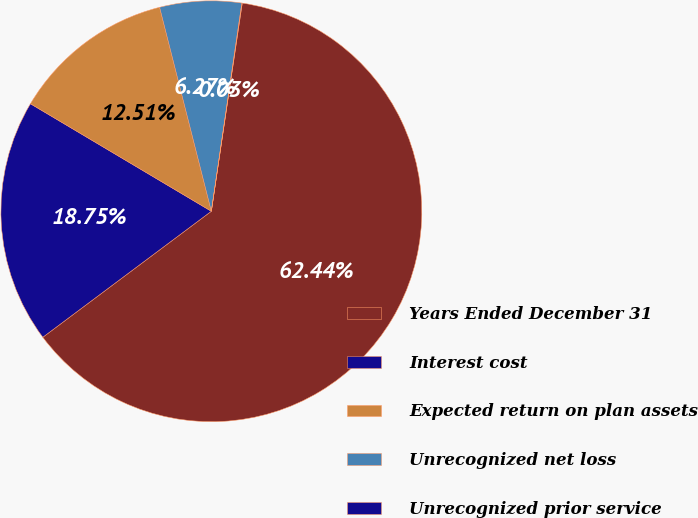Convert chart. <chart><loc_0><loc_0><loc_500><loc_500><pie_chart><fcel>Years Ended December 31<fcel>Interest cost<fcel>Expected return on plan assets<fcel>Unrecognized net loss<fcel>Unrecognized prior service<nl><fcel>62.43%<fcel>18.75%<fcel>12.51%<fcel>6.27%<fcel>0.03%<nl></chart> 